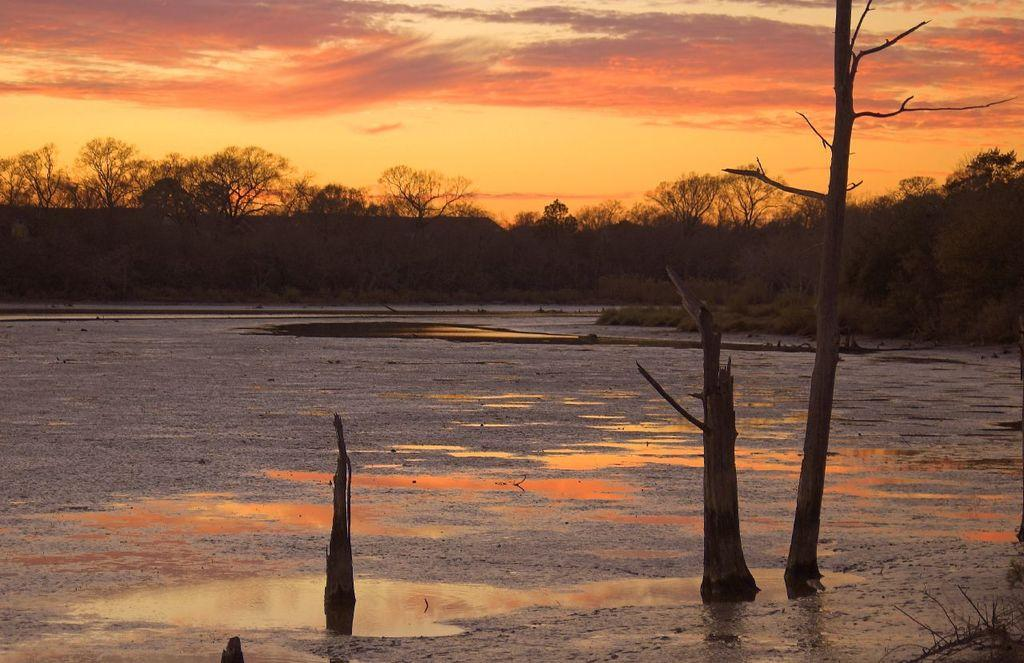What is the main subject in the center of the image? There is water in the center of the image. What can be seen in the background of the image? There are trees and clouds in the background of the image. What else is visible in the background of the image? The sky is visible in the background of the image. How many rings are visible in the water in the image? There are no rings visible in the water in the image. 